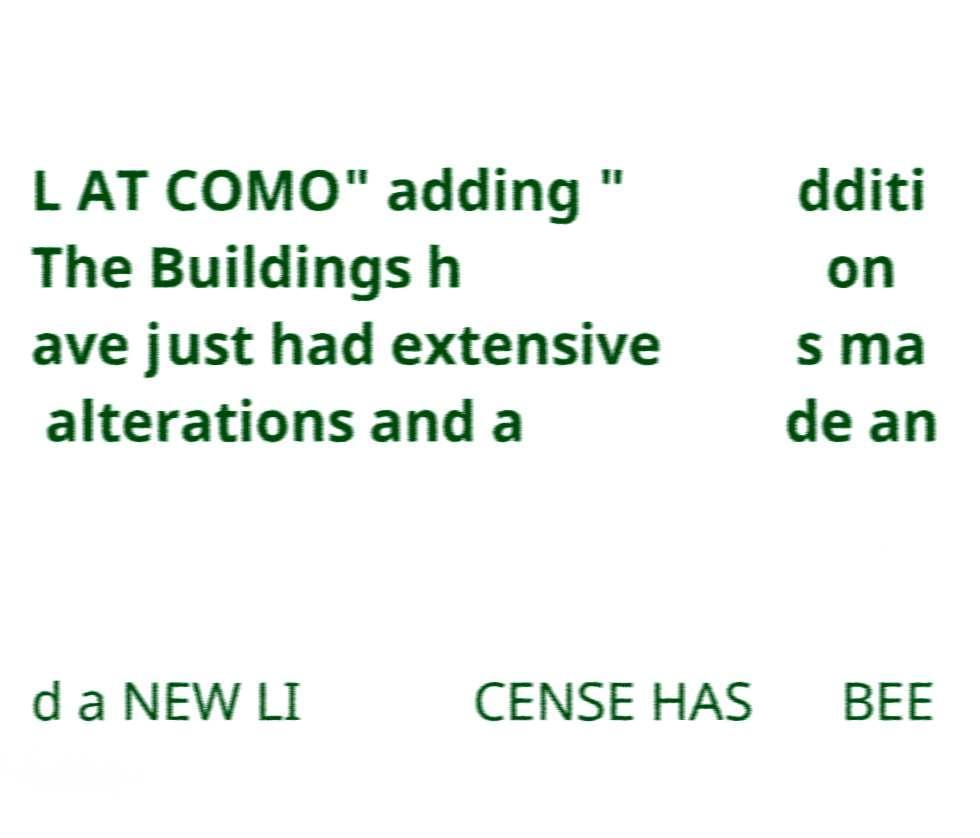Can you accurately transcribe the text from the provided image for me? L AT COMO" adding " The Buildings h ave just had extensive alterations and a dditi on s ma de an d a NEW LI CENSE HAS BEE 